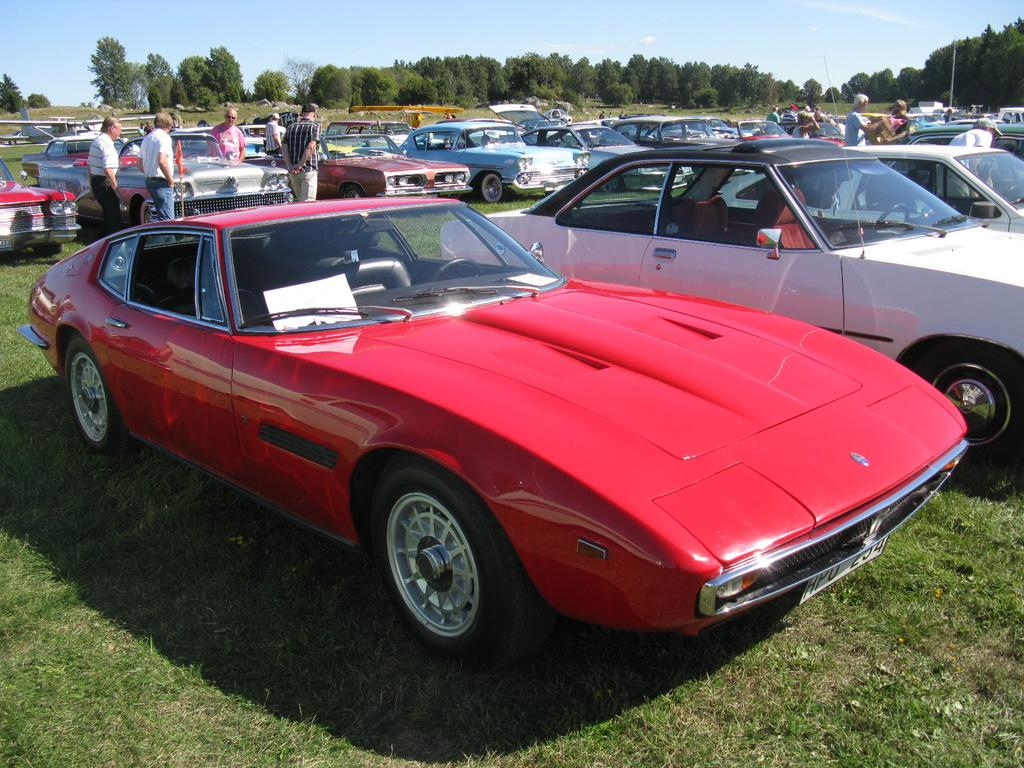What types of objects can be seen in the image? There are vehicles and persons in the image. What natural elements are present in the image? There are trees and grass on the ground in the image. What type of glass can be seen in the image? There is no glass present in the image. What park is visible in the image? The image does not depict a park; it contains vehicles, persons, trees, and grass. 